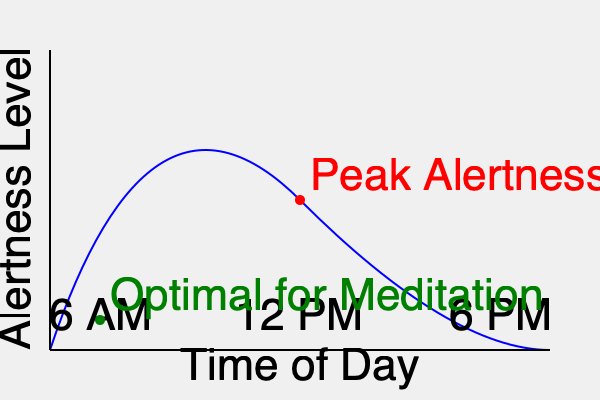Based on the circadian rhythm chart shown, which time of day would be most suitable for implementing a guided meditation feature in your mindfulness app, and why? To determine the optimal time for guided meditation in a mindfulness app, we need to analyze the circadian rhythm chart:

1. The blue curve represents alertness levels throughout the day.
2. The x-axis shows the time of day, from 6 AM to 6 PM.
3. The y-axis indicates the level of alertness.
4. The red dot marks the peak alertness, which occurs around midday.
5. The green dot indicates an optimal time for meditation, which is in the early morning.

Guided meditation is often most effective when:
a) The mind is calm and not overly alert
b) There are fewer distractions
c) The body is naturally transitioning from sleep to wakefulness

The early morning (around 6 AM) is ideal because:
1. Alertness levels are relatively low, making it easier to focus on meditation.
2. The body is naturally transitioning from sleep to wakefulness, which aligns with mindfulness practices.
3. There are typically fewer external distractions at this time.
4. It helps set a positive tone for the rest of the day.

In contrast, implementing meditation at peak alertness (midday) might be less effective due to higher mental activity and potential distractions.
Answer: Early morning (around 6 AM) 